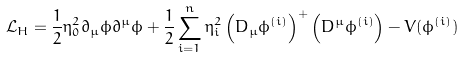Convert formula to latex. <formula><loc_0><loc_0><loc_500><loc_500>\mathcal { L } _ { H } = \frac { 1 } { 2 } \eta _ { 0 } ^ { 2 } \partial _ { \mu } \phi \partial ^ { \mu } \phi + \frac { 1 } { 2 } \sum _ { i = 1 } ^ { n } \eta _ { i } ^ { 2 } \left ( D _ { \mu } \phi ^ { ( i ) } \right ) ^ { + } \left ( D ^ { \mu } \phi ^ { ( i ) } \right ) - V ( \phi ^ { ( i ) } )</formula> 